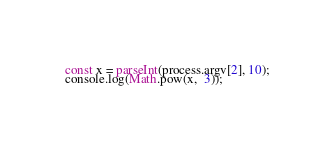<code> <loc_0><loc_0><loc_500><loc_500><_JavaScript_>const x = parseInt(process.argv[2], 10);
console.log(Math.pow(x,  3));
</code> 